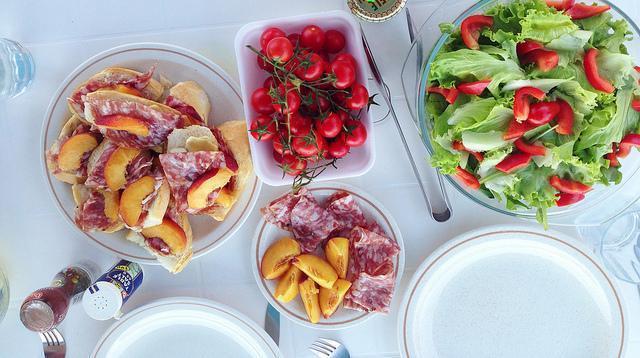How many bowls are there?
Give a very brief answer. 4. How many bottles can you see?
Give a very brief answer. 2. 